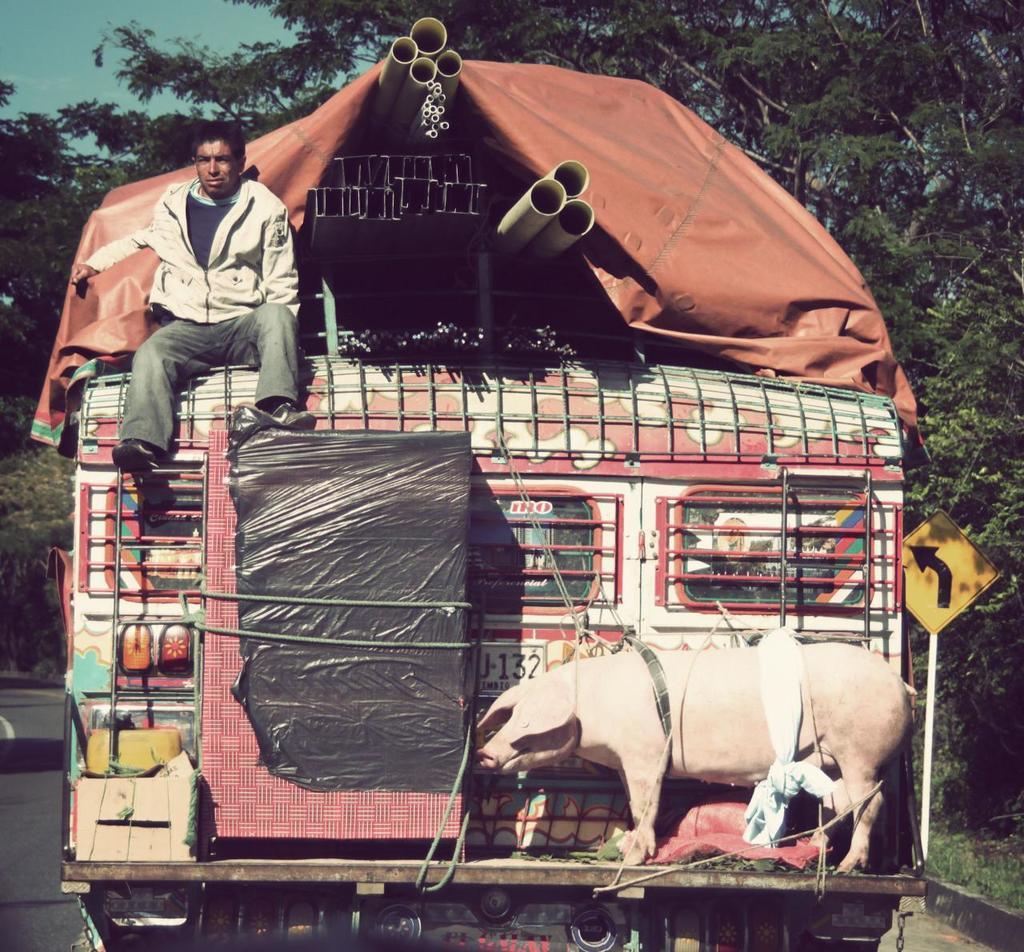Can you describe this image briefly? In this image we can see there is a person sitting in the truck and we can see this truck is fully loaded. 